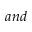<formula> <loc_0><loc_0><loc_500><loc_500>a n d</formula> 